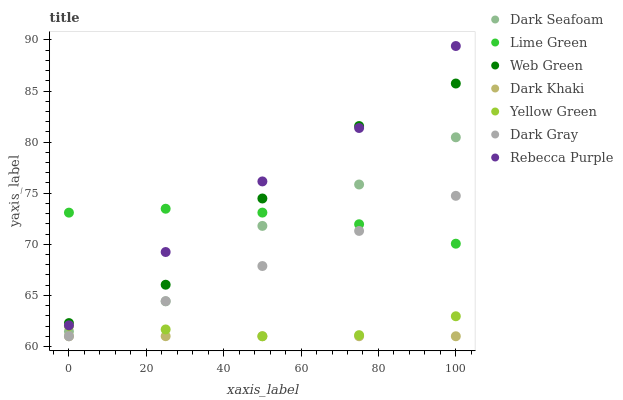Does Dark Khaki have the minimum area under the curve?
Answer yes or no. Yes. Does Rebecca Purple have the maximum area under the curve?
Answer yes or no. Yes. Does Yellow Green have the minimum area under the curve?
Answer yes or no. No. Does Yellow Green have the maximum area under the curve?
Answer yes or no. No. Is Dark Gray the smoothest?
Answer yes or no. Yes. Is Web Green the roughest?
Answer yes or no. Yes. Is Yellow Green the smoothest?
Answer yes or no. No. Is Yellow Green the roughest?
Answer yes or no. No. Does Dark Gray have the lowest value?
Answer yes or no. Yes. Does Web Green have the lowest value?
Answer yes or no. No. Does Rebecca Purple have the highest value?
Answer yes or no. Yes. Does Yellow Green have the highest value?
Answer yes or no. No. Is Dark Gray less than Rebecca Purple?
Answer yes or no. Yes. Is Web Green greater than Dark Khaki?
Answer yes or no. Yes. Does Dark Seafoam intersect Yellow Green?
Answer yes or no. Yes. Is Dark Seafoam less than Yellow Green?
Answer yes or no. No. Is Dark Seafoam greater than Yellow Green?
Answer yes or no. No. Does Dark Gray intersect Rebecca Purple?
Answer yes or no. No. 